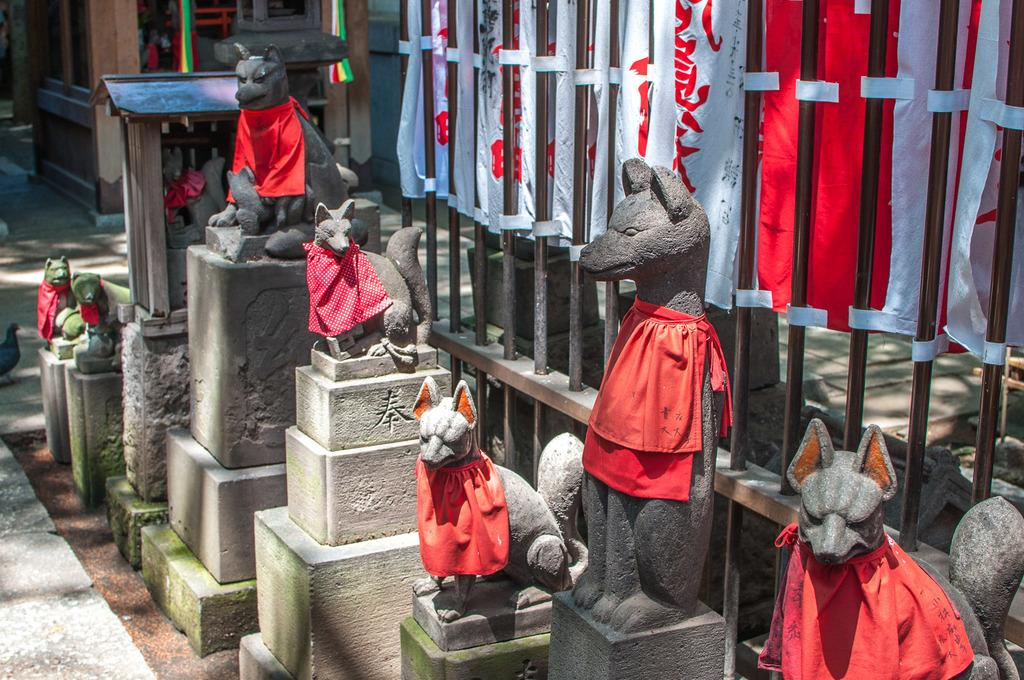What type of statues can be seen in the image? There are statues of dogs in the image. How are the statues of dogs dressed? The statues of dogs are dressed with a cloth. What architectural feature is visible in the image? There is a fence visible in the image. What type of skin condition can be seen on the dogs in the image? There are no dogs present in the image, only statues of dogs, and statues do not have skin conditions. 